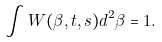Convert formula to latex. <formula><loc_0><loc_0><loc_500><loc_500>\int W ( \beta , t , s ) d ^ { 2 } \beta = 1 .</formula> 